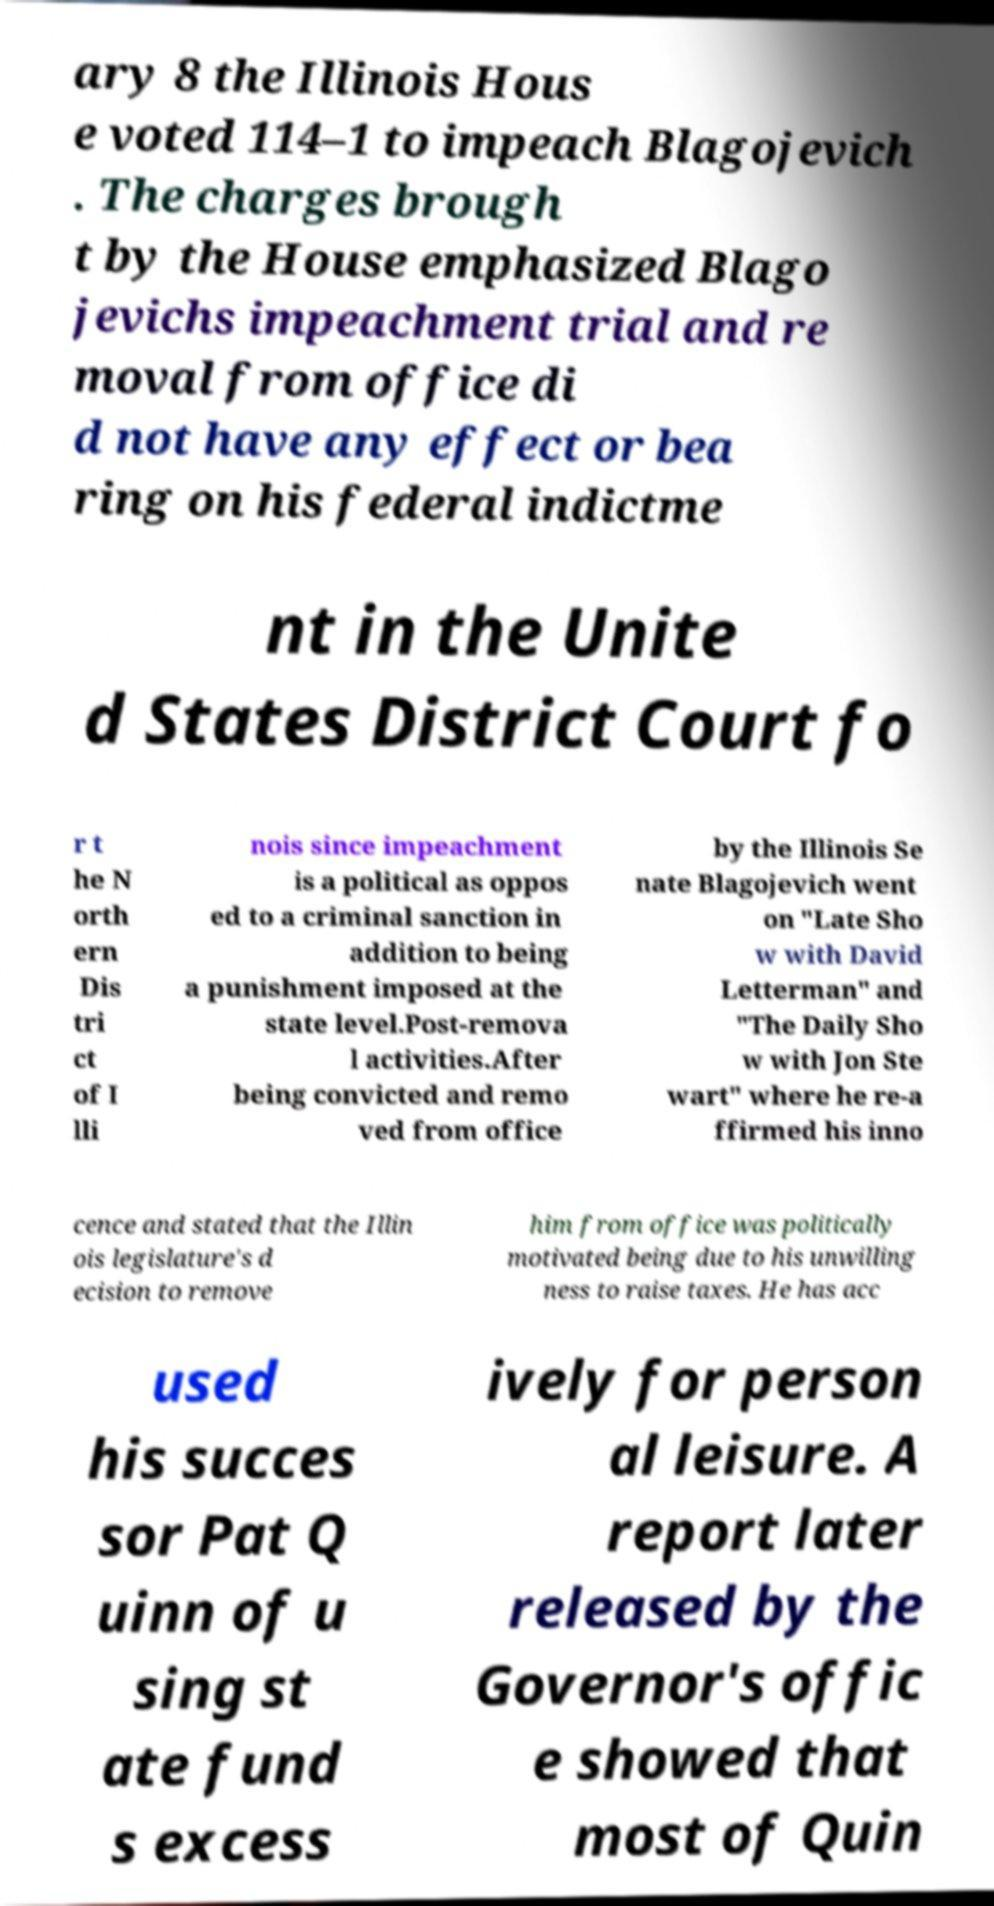Please read and relay the text visible in this image. What does it say? ary 8 the Illinois Hous e voted 114–1 to impeach Blagojevich . The charges brough t by the House emphasized Blago jevichs impeachment trial and re moval from office di d not have any effect or bea ring on his federal indictme nt in the Unite d States District Court fo r t he N orth ern Dis tri ct of I lli nois since impeachment is a political as oppos ed to a criminal sanction in addition to being a punishment imposed at the state level.Post-remova l activities.After being convicted and remo ved from office by the Illinois Se nate Blagojevich went on "Late Sho w with David Letterman" and "The Daily Sho w with Jon Ste wart" where he re-a ffirmed his inno cence and stated that the Illin ois legislature's d ecision to remove him from office was politically motivated being due to his unwilling ness to raise taxes. He has acc used his succes sor Pat Q uinn of u sing st ate fund s excess ively for person al leisure. A report later released by the Governor's offic e showed that most of Quin 